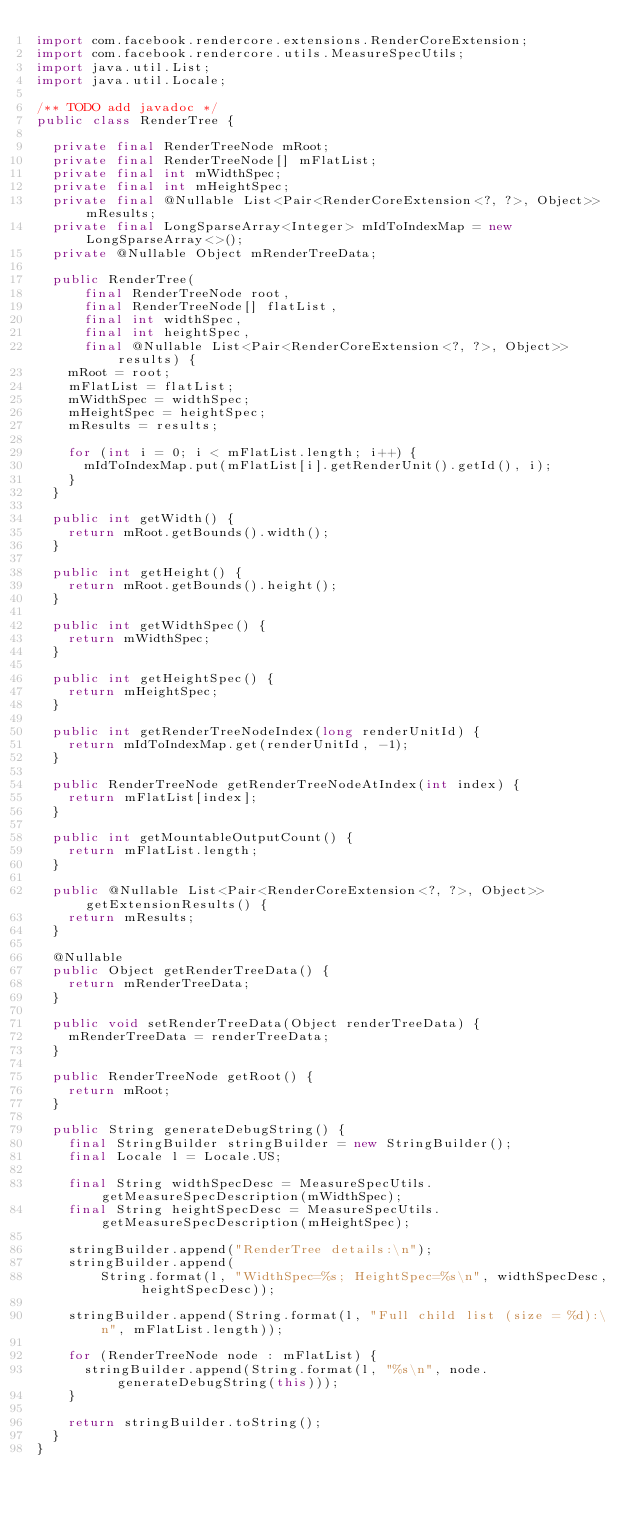<code> <loc_0><loc_0><loc_500><loc_500><_Java_>import com.facebook.rendercore.extensions.RenderCoreExtension;
import com.facebook.rendercore.utils.MeasureSpecUtils;
import java.util.List;
import java.util.Locale;

/** TODO add javadoc */
public class RenderTree {

  private final RenderTreeNode mRoot;
  private final RenderTreeNode[] mFlatList;
  private final int mWidthSpec;
  private final int mHeightSpec;
  private final @Nullable List<Pair<RenderCoreExtension<?, ?>, Object>> mResults;
  private final LongSparseArray<Integer> mIdToIndexMap = new LongSparseArray<>();
  private @Nullable Object mRenderTreeData;

  public RenderTree(
      final RenderTreeNode root,
      final RenderTreeNode[] flatList,
      final int widthSpec,
      final int heightSpec,
      final @Nullable List<Pair<RenderCoreExtension<?, ?>, Object>> results) {
    mRoot = root;
    mFlatList = flatList;
    mWidthSpec = widthSpec;
    mHeightSpec = heightSpec;
    mResults = results;

    for (int i = 0; i < mFlatList.length; i++) {
      mIdToIndexMap.put(mFlatList[i].getRenderUnit().getId(), i);
    }
  }

  public int getWidth() {
    return mRoot.getBounds().width();
  }

  public int getHeight() {
    return mRoot.getBounds().height();
  }

  public int getWidthSpec() {
    return mWidthSpec;
  }

  public int getHeightSpec() {
    return mHeightSpec;
  }

  public int getRenderTreeNodeIndex(long renderUnitId) {
    return mIdToIndexMap.get(renderUnitId, -1);
  }

  public RenderTreeNode getRenderTreeNodeAtIndex(int index) {
    return mFlatList[index];
  }

  public int getMountableOutputCount() {
    return mFlatList.length;
  }

  public @Nullable List<Pair<RenderCoreExtension<?, ?>, Object>> getExtensionResults() {
    return mResults;
  }

  @Nullable
  public Object getRenderTreeData() {
    return mRenderTreeData;
  }

  public void setRenderTreeData(Object renderTreeData) {
    mRenderTreeData = renderTreeData;
  }

  public RenderTreeNode getRoot() {
    return mRoot;
  }

  public String generateDebugString() {
    final StringBuilder stringBuilder = new StringBuilder();
    final Locale l = Locale.US;

    final String widthSpecDesc = MeasureSpecUtils.getMeasureSpecDescription(mWidthSpec);
    final String heightSpecDesc = MeasureSpecUtils.getMeasureSpecDescription(mHeightSpec);

    stringBuilder.append("RenderTree details:\n");
    stringBuilder.append(
        String.format(l, "WidthSpec=%s; HeightSpec=%s\n", widthSpecDesc, heightSpecDesc));

    stringBuilder.append(String.format(l, "Full child list (size = %d):\n", mFlatList.length));

    for (RenderTreeNode node : mFlatList) {
      stringBuilder.append(String.format(l, "%s\n", node.generateDebugString(this)));
    }

    return stringBuilder.toString();
  }
}
</code> 